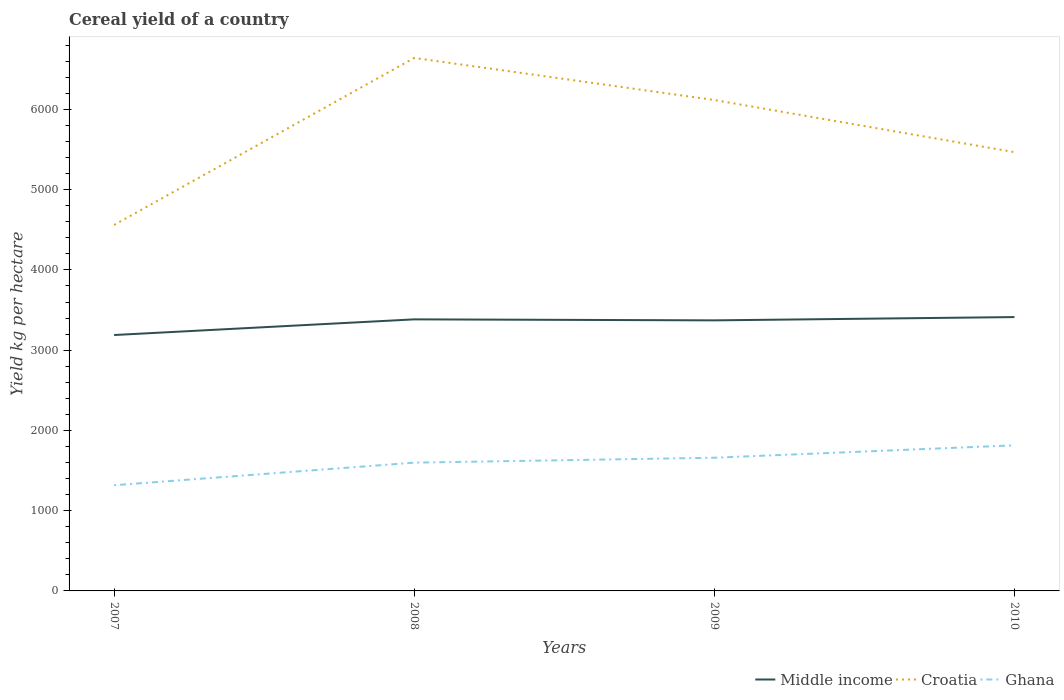Does the line corresponding to Croatia intersect with the line corresponding to Middle income?
Provide a short and direct response. No. Is the number of lines equal to the number of legend labels?
Provide a short and direct response. Yes. Across all years, what is the maximum total cereal yield in Ghana?
Make the answer very short. 1316.97. In which year was the total cereal yield in Croatia maximum?
Offer a very short reply. 2007. What is the total total cereal yield in Ghana in the graph?
Provide a succinct answer. -497.35. What is the difference between the highest and the second highest total cereal yield in Middle income?
Offer a terse response. 223.69. What is the difference between the highest and the lowest total cereal yield in Ghana?
Offer a very short reply. 3. Is the total cereal yield in Ghana strictly greater than the total cereal yield in Middle income over the years?
Provide a short and direct response. Yes. Are the values on the major ticks of Y-axis written in scientific E-notation?
Make the answer very short. No. Does the graph contain any zero values?
Make the answer very short. No. Where does the legend appear in the graph?
Your response must be concise. Bottom right. How many legend labels are there?
Provide a succinct answer. 3. What is the title of the graph?
Your response must be concise. Cereal yield of a country. What is the label or title of the X-axis?
Provide a short and direct response. Years. What is the label or title of the Y-axis?
Your response must be concise. Yield kg per hectare. What is the Yield kg per hectare of Middle income in 2007?
Offer a very short reply. 3188.69. What is the Yield kg per hectare in Croatia in 2007?
Your answer should be compact. 4560.37. What is the Yield kg per hectare in Ghana in 2007?
Make the answer very short. 1316.97. What is the Yield kg per hectare in Middle income in 2008?
Give a very brief answer. 3383.87. What is the Yield kg per hectare of Croatia in 2008?
Offer a very short reply. 6641.36. What is the Yield kg per hectare in Ghana in 2008?
Your answer should be very brief. 1598.13. What is the Yield kg per hectare in Middle income in 2009?
Offer a terse response. 3371.41. What is the Yield kg per hectare in Croatia in 2009?
Your answer should be very brief. 6117.04. What is the Yield kg per hectare of Ghana in 2009?
Make the answer very short. 1659.83. What is the Yield kg per hectare of Middle income in 2010?
Make the answer very short. 3412.38. What is the Yield kg per hectare in Croatia in 2010?
Keep it short and to the point. 5467.4. What is the Yield kg per hectare of Ghana in 2010?
Provide a succinct answer. 1814.31. Across all years, what is the maximum Yield kg per hectare in Middle income?
Your answer should be very brief. 3412.38. Across all years, what is the maximum Yield kg per hectare of Croatia?
Your response must be concise. 6641.36. Across all years, what is the maximum Yield kg per hectare in Ghana?
Provide a short and direct response. 1814.31. Across all years, what is the minimum Yield kg per hectare of Middle income?
Offer a terse response. 3188.69. Across all years, what is the minimum Yield kg per hectare of Croatia?
Ensure brevity in your answer.  4560.37. Across all years, what is the minimum Yield kg per hectare in Ghana?
Offer a very short reply. 1316.97. What is the total Yield kg per hectare of Middle income in the graph?
Your response must be concise. 1.34e+04. What is the total Yield kg per hectare of Croatia in the graph?
Keep it short and to the point. 2.28e+04. What is the total Yield kg per hectare in Ghana in the graph?
Keep it short and to the point. 6389.24. What is the difference between the Yield kg per hectare in Middle income in 2007 and that in 2008?
Provide a succinct answer. -195.19. What is the difference between the Yield kg per hectare in Croatia in 2007 and that in 2008?
Keep it short and to the point. -2080.99. What is the difference between the Yield kg per hectare of Ghana in 2007 and that in 2008?
Ensure brevity in your answer.  -281.17. What is the difference between the Yield kg per hectare of Middle income in 2007 and that in 2009?
Your response must be concise. -182.72. What is the difference between the Yield kg per hectare in Croatia in 2007 and that in 2009?
Offer a very short reply. -1556.67. What is the difference between the Yield kg per hectare of Ghana in 2007 and that in 2009?
Ensure brevity in your answer.  -342.86. What is the difference between the Yield kg per hectare in Middle income in 2007 and that in 2010?
Ensure brevity in your answer.  -223.69. What is the difference between the Yield kg per hectare in Croatia in 2007 and that in 2010?
Your answer should be very brief. -907.03. What is the difference between the Yield kg per hectare in Ghana in 2007 and that in 2010?
Keep it short and to the point. -497.35. What is the difference between the Yield kg per hectare in Middle income in 2008 and that in 2009?
Keep it short and to the point. 12.47. What is the difference between the Yield kg per hectare in Croatia in 2008 and that in 2009?
Your answer should be compact. 524.32. What is the difference between the Yield kg per hectare in Ghana in 2008 and that in 2009?
Keep it short and to the point. -61.7. What is the difference between the Yield kg per hectare of Middle income in 2008 and that in 2010?
Your response must be concise. -28.51. What is the difference between the Yield kg per hectare of Croatia in 2008 and that in 2010?
Offer a terse response. 1173.96. What is the difference between the Yield kg per hectare of Ghana in 2008 and that in 2010?
Make the answer very short. -216.18. What is the difference between the Yield kg per hectare in Middle income in 2009 and that in 2010?
Provide a short and direct response. -40.97. What is the difference between the Yield kg per hectare in Croatia in 2009 and that in 2010?
Provide a succinct answer. 649.64. What is the difference between the Yield kg per hectare in Ghana in 2009 and that in 2010?
Your answer should be compact. -154.49. What is the difference between the Yield kg per hectare in Middle income in 2007 and the Yield kg per hectare in Croatia in 2008?
Provide a succinct answer. -3452.68. What is the difference between the Yield kg per hectare of Middle income in 2007 and the Yield kg per hectare of Ghana in 2008?
Provide a succinct answer. 1590.55. What is the difference between the Yield kg per hectare of Croatia in 2007 and the Yield kg per hectare of Ghana in 2008?
Offer a terse response. 2962.24. What is the difference between the Yield kg per hectare in Middle income in 2007 and the Yield kg per hectare in Croatia in 2009?
Offer a terse response. -2928.35. What is the difference between the Yield kg per hectare of Middle income in 2007 and the Yield kg per hectare of Ghana in 2009?
Give a very brief answer. 1528.86. What is the difference between the Yield kg per hectare of Croatia in 2007 and the Yield kg per hectare of Ghana in 2009?
Offer a terse response. 2900.55. What is the difference between the Yield kg per hectare of Middle income in 2007 and the Yield kg per hectare of Croatia in 2010?
Give a very brief answer. -2278.72. What is the difference between the Yield kg per hectare in Middle income in 2007 and the Yield kg per hectare in Ghana in 2010?
Ensure brevity in your answer.  1374.37. What is the difference between the Yield kg per hectare of Croatia in 2007 and the Yield kg per hectare of Ghana in 2010?
Keep it short and to the point. 2746.06. What is the difference between the Yield kg per hectare of Middle income in 2008 and the Yield kg per hectare of Croatia in 2009?
Give a very brief answer. -2733.17. What is the difference between the Yield kg per hectare of Middle income in 2008 and the Yield kg per hectare of Ghana in 2009?
Offer a terse response. 1724.05. What is the difference between the Yield kg per hectare of Croatia in 2008 and the Yield kg per hectare of Ghana in 2009?
Your answer should be very brief. 4981.53. What is the difference between the Yield kg per hectare in Middle income in 2008 and the Yield kg per hectare in Croatia in 2010?
Make the answer very short. -2083.53. What is the difference between the Yield kg per hectare of Middle income in 2008 and the Yield kg per hectare of Ghana in 2010?
Your answer should be very brief. 1569.56. What is the difference between the Yield kg per hectare in Croatia in 2008 and the Yield kg per hectare in Ghana in 2010?
Offer a terse response. 4827.05. What is the difference between the Yield kg per hectare in Middle income in 2009 and the Yield kg per hectare in Croatia in 2010?
Offer a very short reply. -2095.99. What is the difference between the Yield kg per hectare of Middle income in 2009 and the Yield kg per hectare of Ghana in 2010?
Provide a succinct answer. 1557.09. What is the difference between the Yield kg per hectare in Croatia in 2009 and the Yield kg per hectare in Ghana in 2010?
Provide a short and direct response. 4302.73. What is the average Yield kg per hectare in Middle income per year?
Provide a short and direct response. 3339.09. What is the average Yield kg per hectare of Croatia per year?
Offer a very short reply. 5696.54. What is the average Yield kg per hectare in Ghana per year?
Your answer should be compact. 1597.31. In the year 2007, what is the difference between the Yield kg per hectare of Middle income and Yield kg per hectare of Croatia?
Offer a very short reply. -1371.69. In the year 2007, what is the difference between the Yield kg per hectare in Middle income and Yield kg per hectare in Ghana?
Offer a terse response. 1871.72. In the year 2007, what is the difference between the Yield kg per hectare of Croatia and Yield kg per hectare of Ghana?
Give a very brief answer. 3243.41. In the year 2008, what is the difference between the Yield kg per hectare in Middle income and Yield kg per hectare in Croatia?
Your answer should be compact. -3257.49. In the year 2008, what is the difference between the Yield kg per hectare in Middle income and Yield kg per hectare in Ghana?
Your response must be concise. 1785.74. In the year 2008, what is the difference between the Yield kg per hectare of Croatia and Yield kg per hectare of Ghana?
Give a very brief answer. 5043.23. In the year 2009, what is the difference between the Yield kg per hectare in Middle income and Yield kg per hectare in Croatia?
Provide a succinct answer. -2745.63. In the year 2009, what is the difference between the Yield kg per hectare of Middle income and Yield kg per hectare of Ghana?
Give a very brief answer. 1711.58. In the year 2009, what is the difference between the Yield kg per hectare of Croatia and Yield kg per hectare of Ghana?
Offer a very short reply. 4457.21. In the year 2010, what is the difference between the Yield kg per hectare of Middle income and Yield kg per hectare of Croatia?
Give a very brief answer. -2055.02. In the year 2010, what is the difference between the Yield kg per hectare in Middle income and Yield kg per hectare in Ghana?
Make the answer very short. 1598.07. In the year 2010, what is the difference between the Yield kg per hectare in Croatia and Yield kg per hectare in Ghana?
Offer a terse response. 3653.09. What is the ratio of the Yield kg per hectare of Middle income in 2007 to that in 2008?
Ensure brevity in your answer.  0.94. What is the ratio of the Yield kg per hectare in Croatia in 2007 to that in 2008?
Offer a terse response. 0.69. What is the ratio of the Yield kg per hectare of Ghana in 2007 to that in 2008?
Provide a short and direct response. 0.82. What is the ratio of the Yield kg per hectare of Middle income in 2007 to that in 2009?
Your answer should be compact. 0.95. What is the ratio of the Yield kg per hectare of Croatia in 2007 to that in 2009?
Give a very brief answer. 0.75. What is the ratio of the Yield kg per hectare of Ghana in 2007 to that in 2009?
Your answer should be compact. 0.79. What is the ratio of the Yield kg per hectare in Middle income in 2007 to that in 2010?
Your answer should be very brief. 0.93. What is the ratio of the Yield kg per hectare in Croatia in 2007 to that in 2010?
Make the answer very short. 0.83. What is the ratio of the Yield kg per hectare of Ghana in 2007 to that in 2010?
Make the answer very short. 0.73. What is the ratio of the Yield kg per hectare in Croatia in 2008 to that in 2009?
Ensure brevity in your answer.  1.09. What is the ratio of the Yield kg per hectare in Ghana in 2008 to that in 2009?
Make the answer very short. 0.96. What is the ratio of the Yield kg per hectare in Croatia in 2008 to that in 2010?
Your answer should be very brief. 1.21. What is the ratio of the Yield kg per hectare in Ghana in 2008 to that in 2010?
Give a very brief answer. 0.88. What is the ratio of the Yield kg per hectare of Middle income in 2009 to that in 2010?
Offer a very short reply. 0.99. What is the ratio of the Yield kg per hectare in Croatia in 2009 to that in 2010?
Your answer should be very brief. 1.12. What is the ratio of the Yield kg per hectare in Ghana in 2009 to that in 2010?
Your answer should be compact. 0.91. What is the difference between the highest and the second highest Yield kg per hectare in Middle income?
Give a very brief answer. 28.51. What is the difference between the highest and the second highest Yield kg per hectare in Croatia?
Offer a terse response. 524.32. What is the difference between the highest and the second highest Yield kg per hectare of Ghana?
Give a very brief answer. 154.49. What is the difference between the highest and the lowest Yield kg per hectare in Middle income?
Provide a succinct answer. 223.69. What is the difference between the highest and the lowest Yield kg per hectare in Croatia?
Keep it short and to the point. 2080.99. What is the difference between the highest and the lowest Yield kg per hectare of Ghana?
Ensure brevity in your answer.  497.35. 